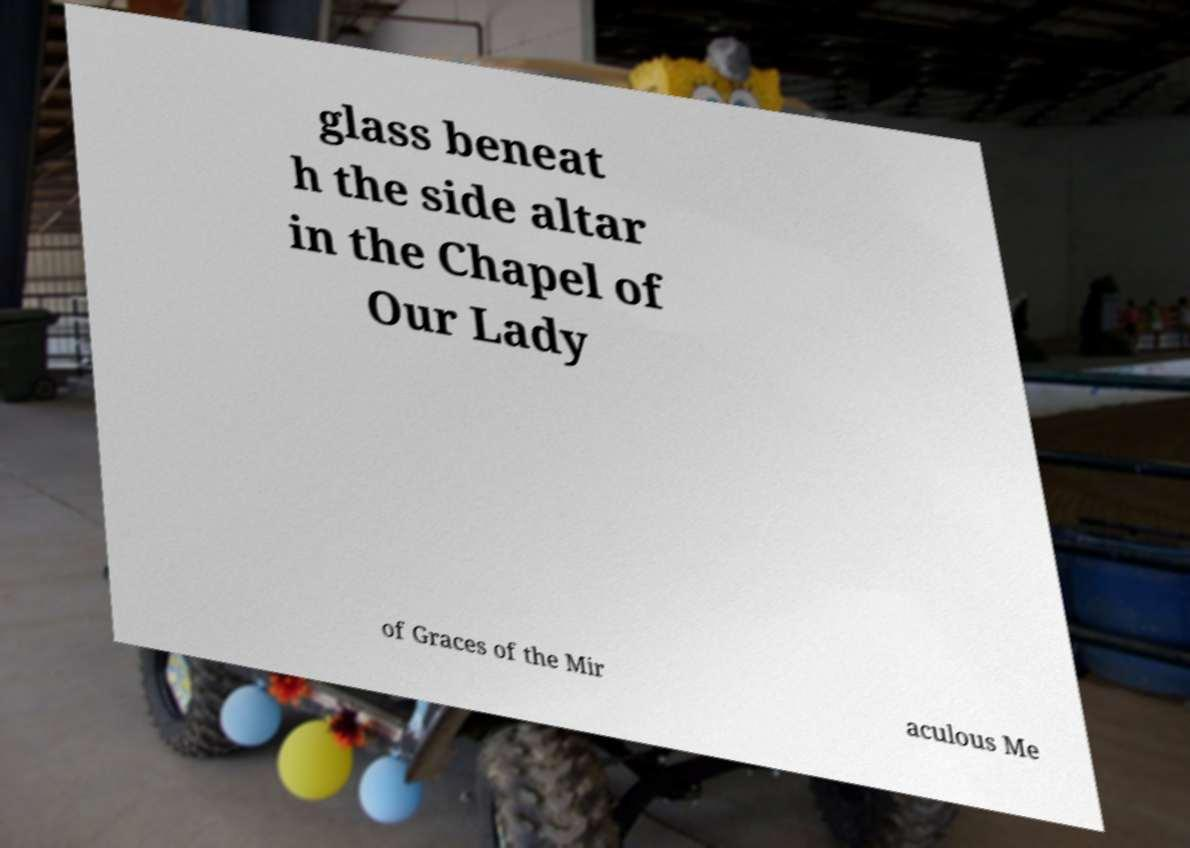I need the written content from this picture converted into text. Can you do that? glass beneat h the side altar in the Chapel of Our Lady of Graces of the Mir aculous Me 